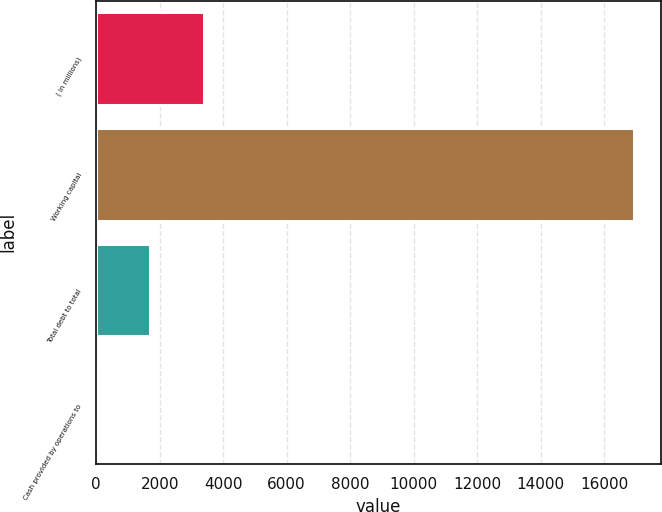Convert chart. <chart><loc_0><loc_0><loc_500><loc_500><bar_chart><fcel>( in millions)<fcel>Working capital<fcel>Total debt to total<fcel>Cash provided by operations to<nl><fcel>3387.77<fcel>16936<fcel>1694.24<fcel>0.71<nl></chart> 